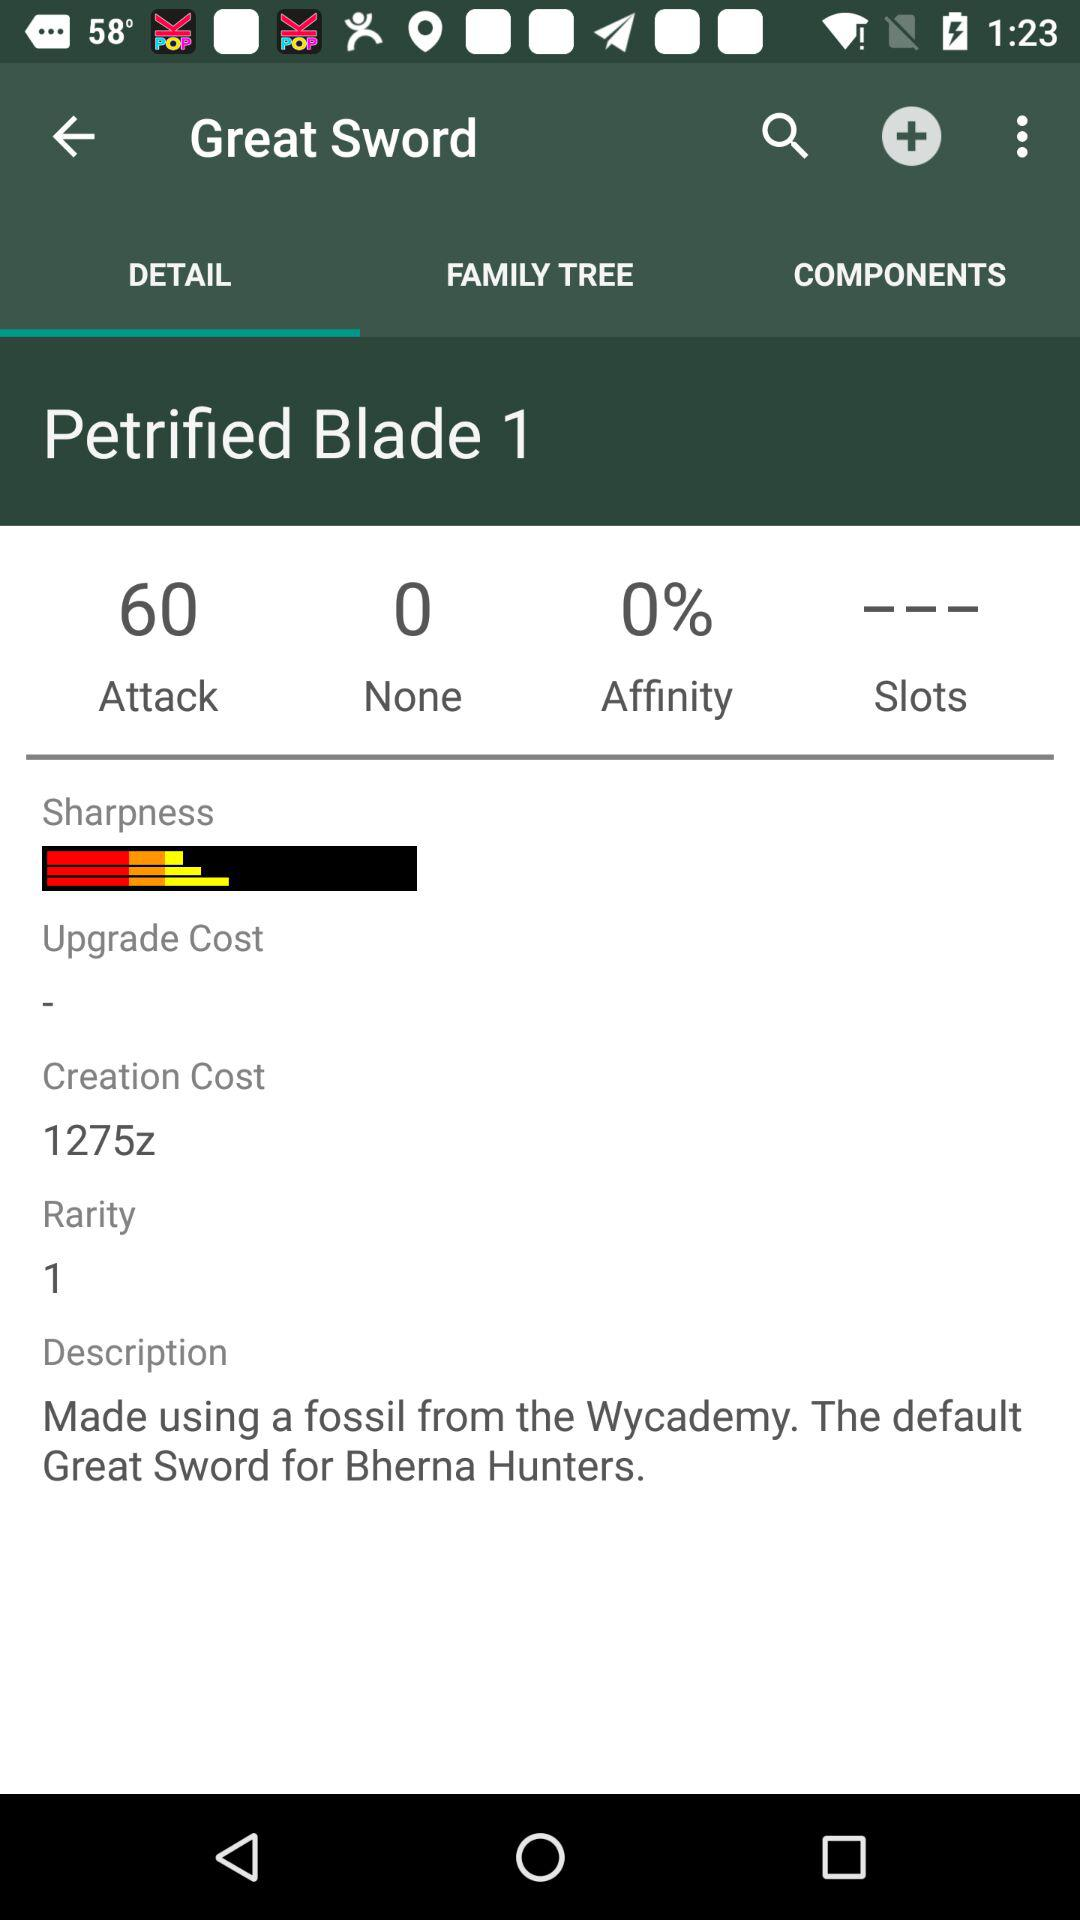What is the creation cost of the "Great Sword"? The creation cost of the "Great Sword" is 1275z. 